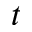Convert formula to latex. <formula><loc_0><loc_0><loc_500><loc_500>t</formula> 